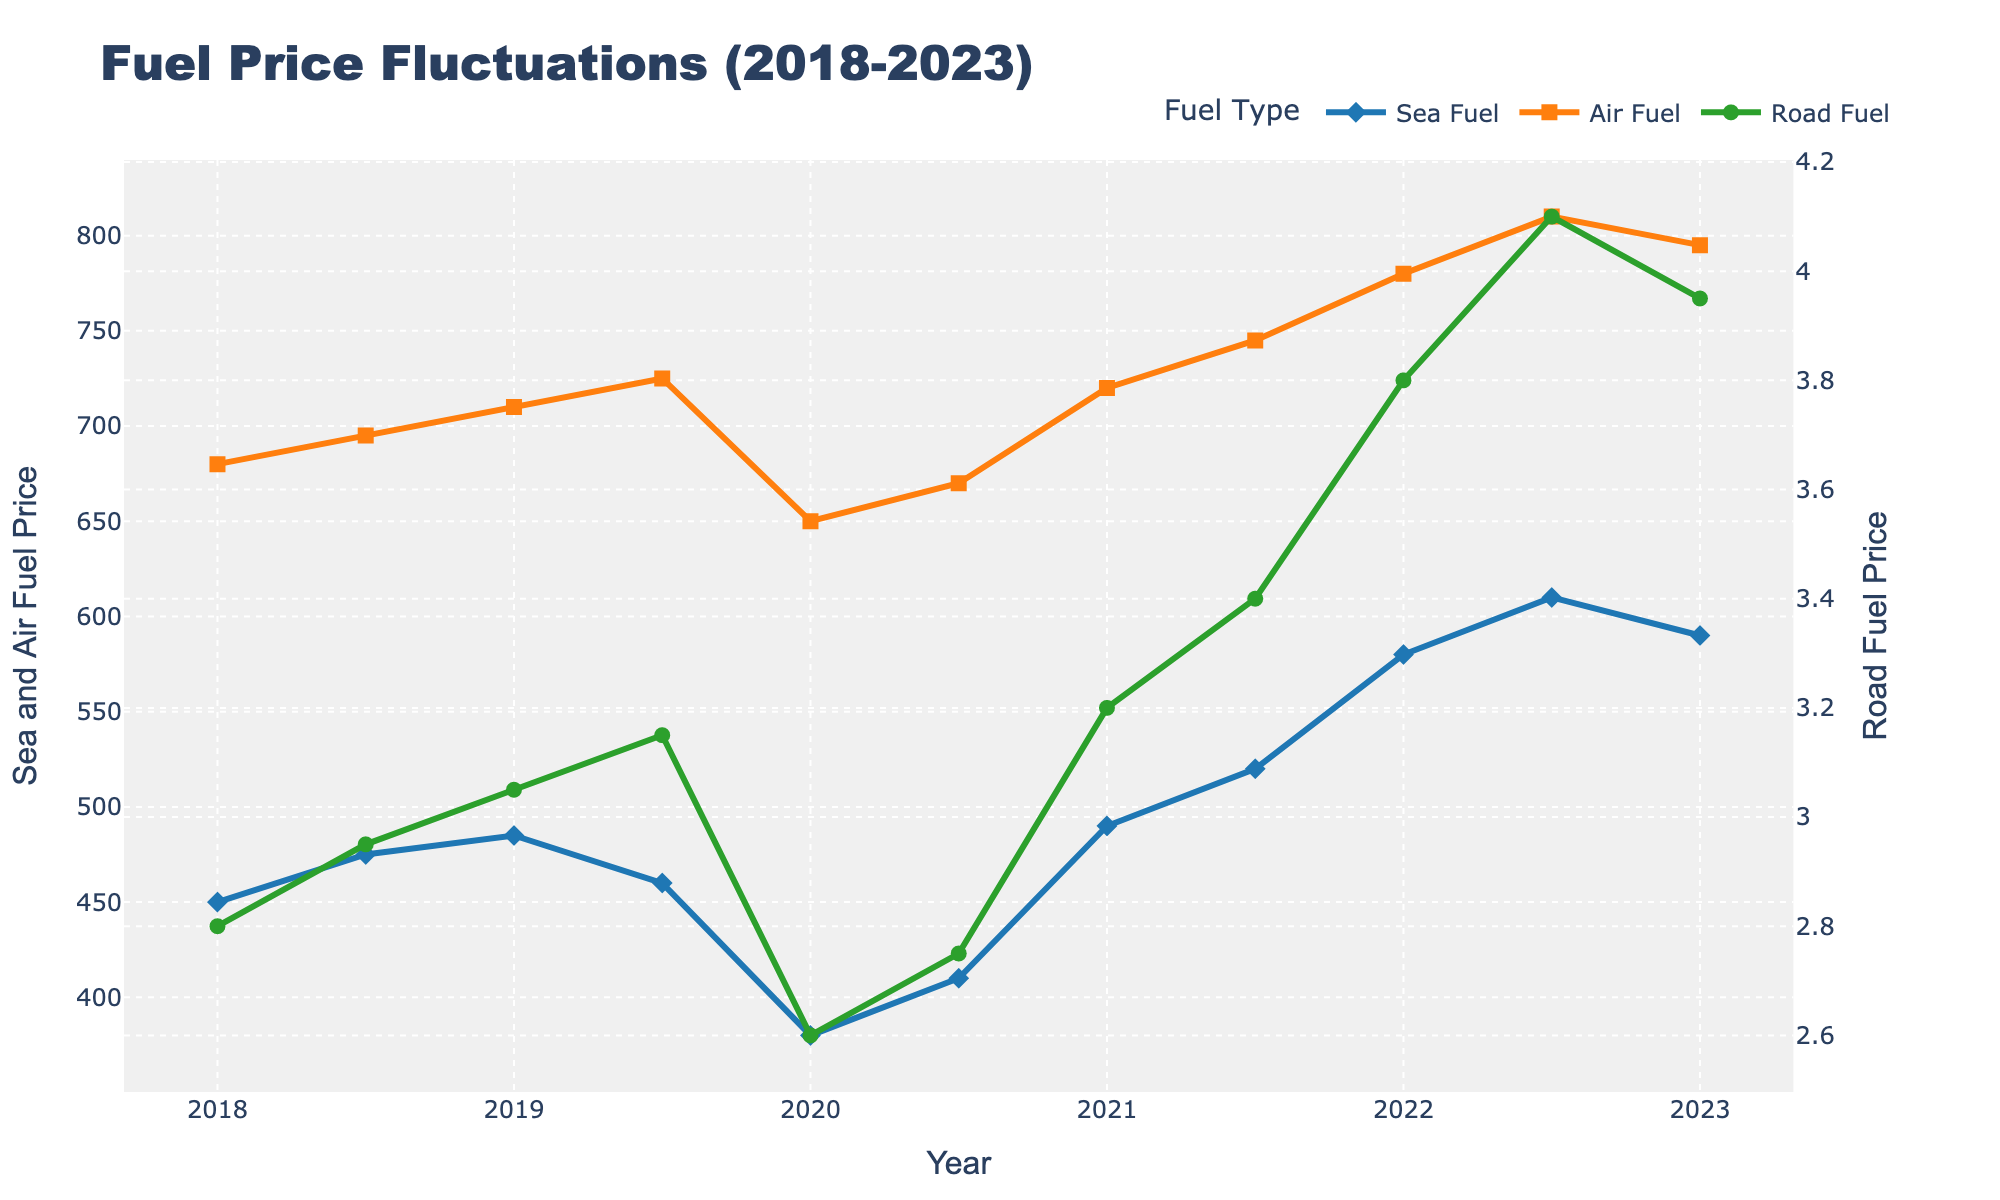What was the trend of Sea Fuel prices between 2020 and 2021? To determine the trend, compare the prices at the beginning and end of 2020 and 2021. In 2020, Sea Fuel moved from 380 to 410, while in 2021, it increased from 490 to 520. Both years show an increasing trend.
Answer: Increasing Which transportation mode had the most volatile fuel price changes over the last 5 years? Volatility can be visually assessed by noting the fluctuations in the plot. Air Fuel has the largest visible swings, starting around 680 in 2018, dropping to 650 in 2020, and then sharply rising to 810 in 2022.
Answer: Air Fuel What was the average Air Fuel price between 2020 and 2023? Calculate the average of Air Fuel prices from 2020 to 2023: (650 + 670 + 720 + 745 + 780 + 810 + 795) / 7. Sum up the prices (650 + 670 + 720 + 745 + 780 + 810 + 795) = 5170, then divide by 7: 5170 / 7 = 738.57.
Answer: 738.57 In which year was the Road Fuel price the highest? Look at the plot for the peak of the Road Fuel line, which occurs at the point corresponding to 2022.5.
Answer: 2022.5 How did the fuel prices for all three modes compare in mid-2019? Check the values for mid-2019 (2019.5): Sea Fuel (460), Air Fuel (725), and Road Fuel (3.15). Air Fuel is the highest, followed by Sea Fuel, and then Road Fuel.
Answer: Air Fuel > Sea Fuel > Road Fuel What was the percentage increase in Road Fuel price from 2020 to 2022? Find the Road Fuel prices at these years: 2020 (2.60) and 2022 (3.80). Calculate the percentage increase: ((3.80 - 2.60) / 2.60) * 100 = 46.15%.
Answer: 46.15% By how much did Sea Fuel prices increase from 2021 to 2022? Subtract the Sea Fuel price of 2021 (490) from the price in 2022 (580): 580 - 490 = 90.
Answer: 90 Which transportation mode consistently showed an upward fuel price trend over the last five years? Examine the overall trend of each mode. Road Fuel shows a generally consistent upward trend from 2.80 in 2018 to 3.95 in 2023.
Answer: Road Fuel How did the Sea Fuel price change between 2019 and 2021? Identify Sea Fuel prices for these years: 2019 (485) to 2021 (490). Although there was a decrease in 2019.5 (460), the overall change from 2019 to 2021 shows it increased from 485 to 490.
Answer: Increased Between which years did Air Fuel see the most significant price spike? Note the largest single-year increase from the plot, which is between 2021.5 (745) and 2022.5 (810).
Answer: 2021.5 to 2022.5 